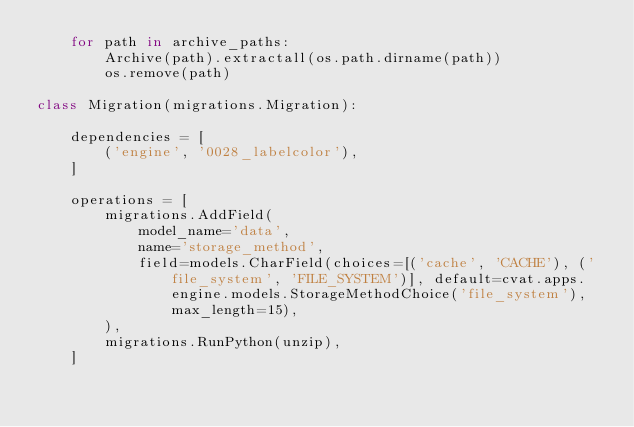<code> <loc_0><loc_0><loc_500><loc_500><_Python_>    for path in archive_paths:
        Archive(path).extractall(os.path.dirname(path))
        os.remove(path)

class Migration(migrations.Migration):

    dependencies = [
        ('engine', '0028_labelcolor'),
    ]

    operations = [
        migrations.AddField(
            model_name='data',
            name='storage_method',
            field=models.CharField(choices=[('cache', 'CACHE'), ('file_system', 'FILE_SYSTEM')], default=cvat.apps.engine.models.StorageMethodChoice('file_system'), max_length=15),
        ),
        migrations.RunPython(unzip),
    ]
</code> 